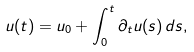Convert formula to latex. <formula><loc_0><loc_0><loc_500><loc_500>u ( t ) = u _ { 0 } + \int _ { 0 } ^ { t } \partial _ { t } u ( s ) \, d s ,</formula> 